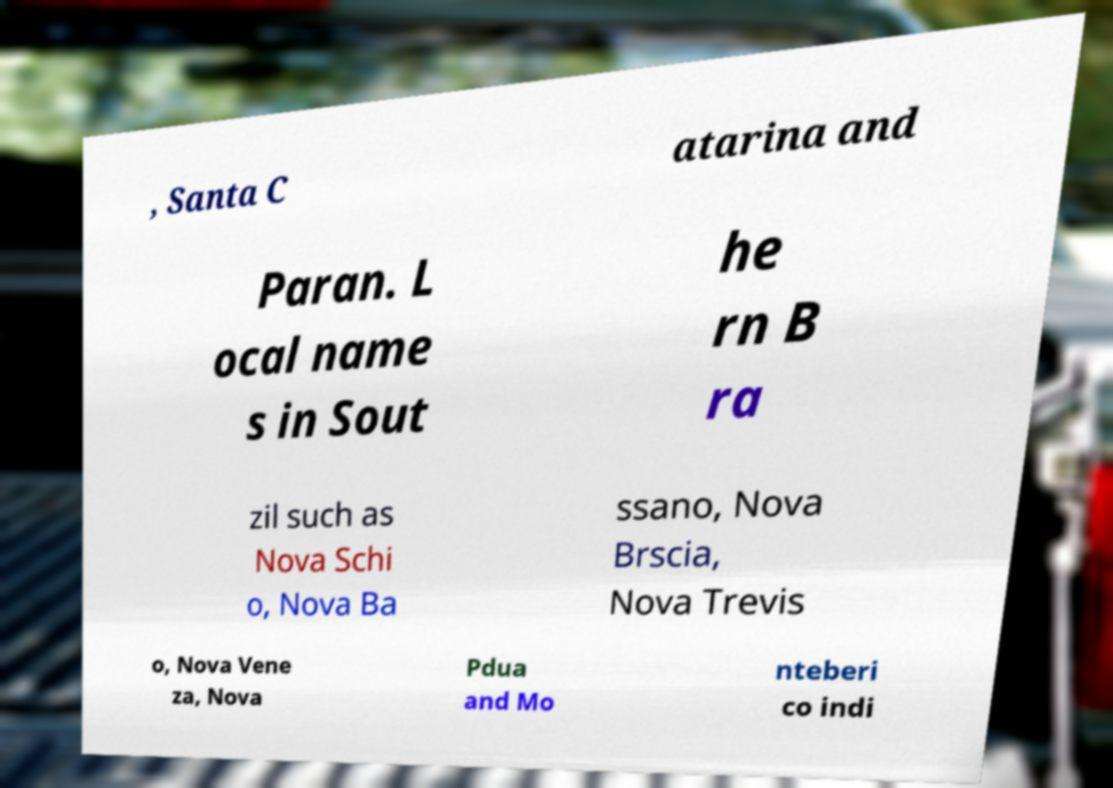Could you extract and type out the text from this image? , Santa C atarina and Paran. L ocal name s in Sout he rn B ra zil such as Nova Schi o, Nova Ba ssano, Nova Brscia, Nova Trevis o, Nova Vene za, Nova Pdua and Mo nteberi co indi 